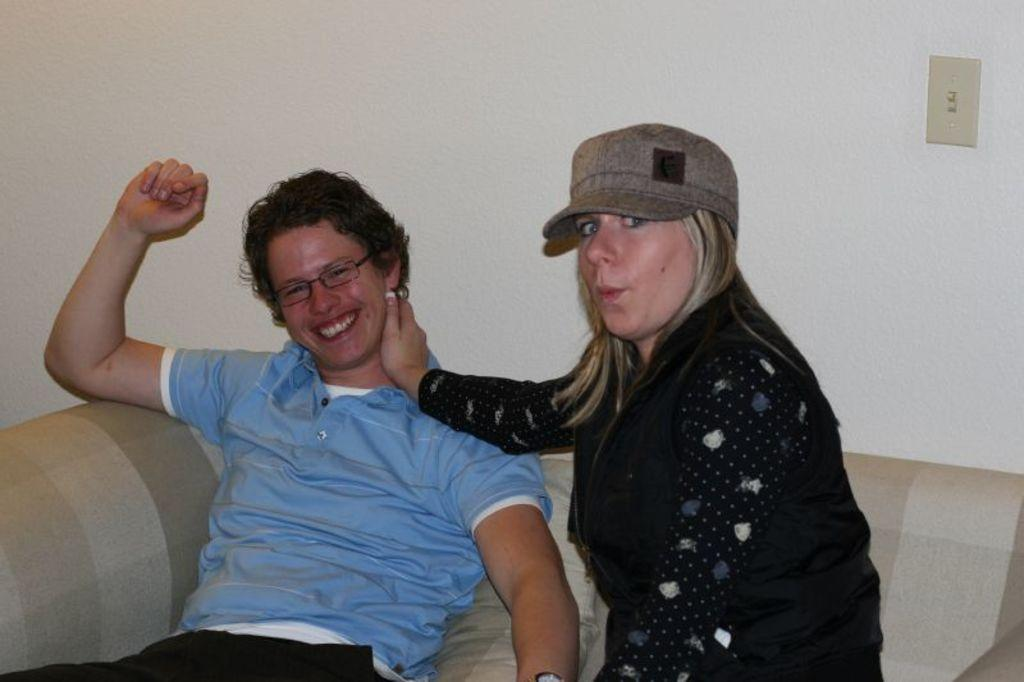What are the people in the image doing? The persons sitting on the sofa in the image are smiling. Can you describe the background of the image? There is a wall in the background of the image. What is on the wall in the image? There is an object on the wall that is cream in color. What type of eggnog can be seen in the image? There is no eggnog present in the image. Is there a parcel being delivered in the image? There is no parcel or delivery depicted in the image. 